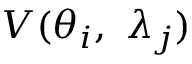<formula> <loc_0><loc_0><loc_500><loc_500>V ( { \theta _ { i } } , \, { \lambda _ { j } } )</formula> 